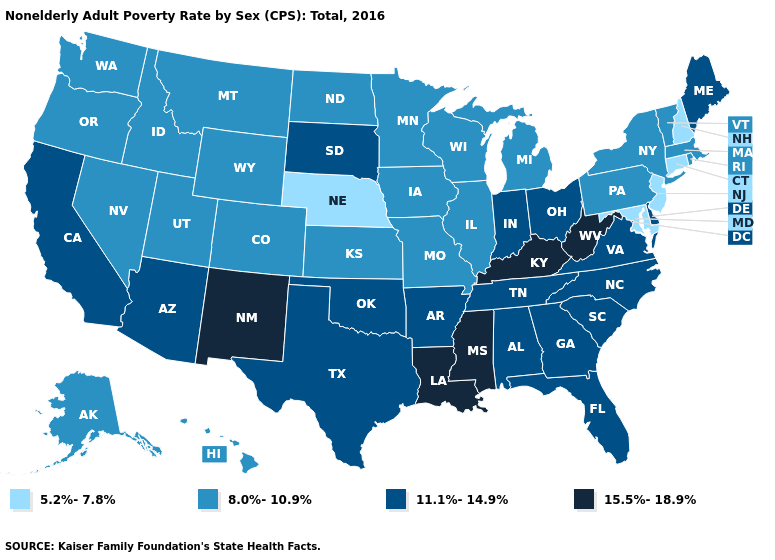What is the lowest value in the South?
Concise answer only. 5.2%-7.8%. Name the states that have a value in the range 15.5%-18.9%?
Short answer required. Kentucky, Louisiana, Mississippi, New Mexico, West Virginia. Name the states that have a value in the range 11.1%-14.9%?
Concise answer only. Alabama, Arizona, Arkansas, California, Delaware, Florida, Georgia, Indiana, Maine, North Carolina, Ohio, Oklahoma, South Carolina, South Dakota, Tennessee, Texas, Virginia. What is the value of New Jersey?
Answer briefly. 5.2%-7.8%. Which states have the highest value in the USA?
Be succinct. Kentucky, Louisiana, Mississippi, New Mexico, West Virginia. Name the states that have a value in the range 8.0%-10.9%?
Be succinct. Alaska, Colorado, Hawaii, Idaho, Illinois, Iowa, Kansas, Massachusetts, Michigan, Minnesota, Missouri, Montana, Nevada, New York, North Dakota, Oregon, Pennsylvania, Rhode Island, Utah, Vermont, Washington, Wisconsin, Wyoming. Name the states that have a value in the range 8.0%-10.9%?
Write a very short answer. Alaska, Colorado, Hawaii, Idaho, Illinois, Iowa, Kansas, Massachusetts, Michigan, Minnesota, Missouri, Montana, Nevada, New York, North Dakota, Oregon, Pennsylvania, Rhode Island, Utah, Vermont, Washington, Wisconsin, Wyoming. Does the first symbol in the legend represent the smallest category?
Quick response, please. Yes. What is the value of North Carolina?
Answer briefly. 11.1%-14.9%. What is the value of Louisiana?
Keep it brief. 15.5%-18.9%. Which states have the lowest value in the USA?
Write a very short answer. Connecticut, Maryland, Nebraska, New Hampshire, New Jersey. What is the value of Alaska?
Give a very brief answer. 8.0%-10.9%. Does the map have missing data?
Concise answer only. No. Name the states that have a value in the range 5.2%-7.8%?
Short answer required. Connecticut, Maryland, Nebraska, New Hampshire, New Jersey. What is the highest value in states that border North Carolina?
Concise answer only. 11.1%-14.9%. 